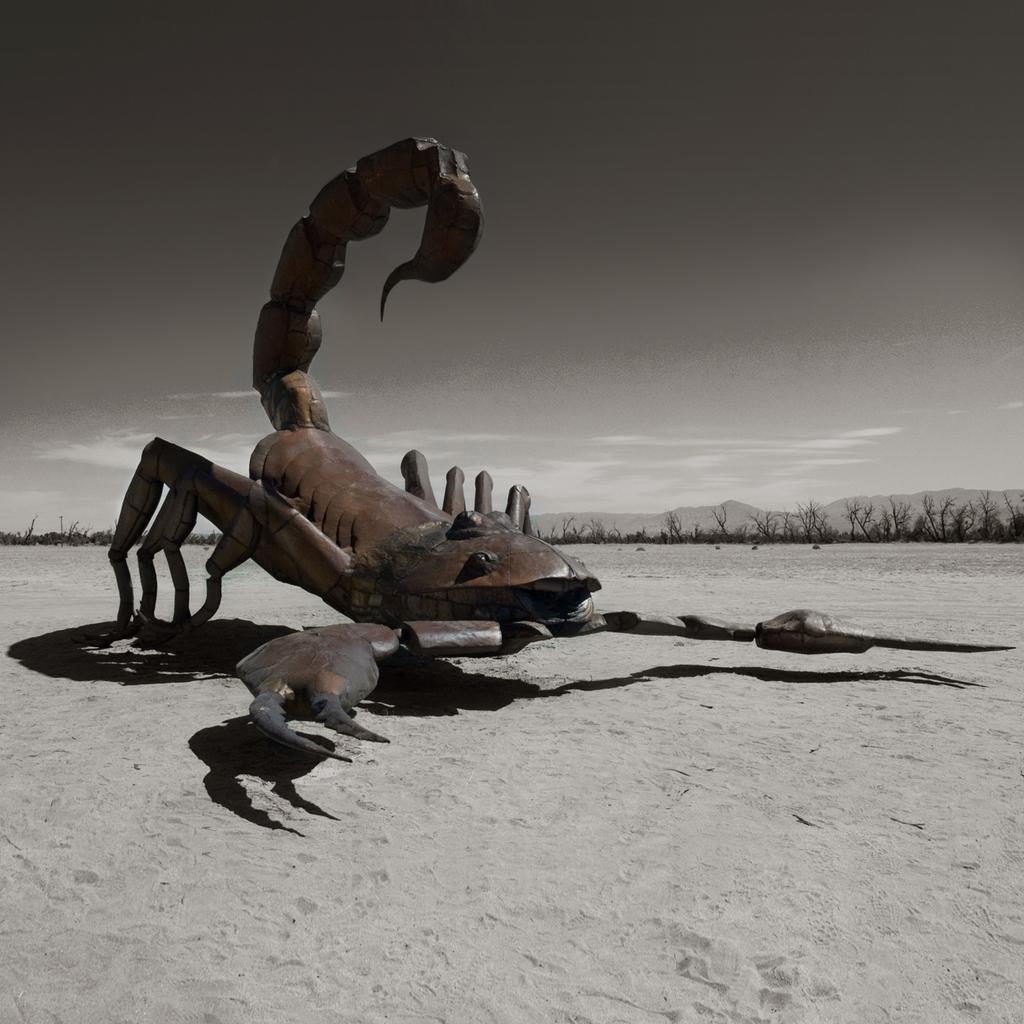Could you give a brief overview of what you see in this image? In this image I can see the scorpion which is in brown and black color. It is on the sand. In the background there are many trees, mountains and the sky. 